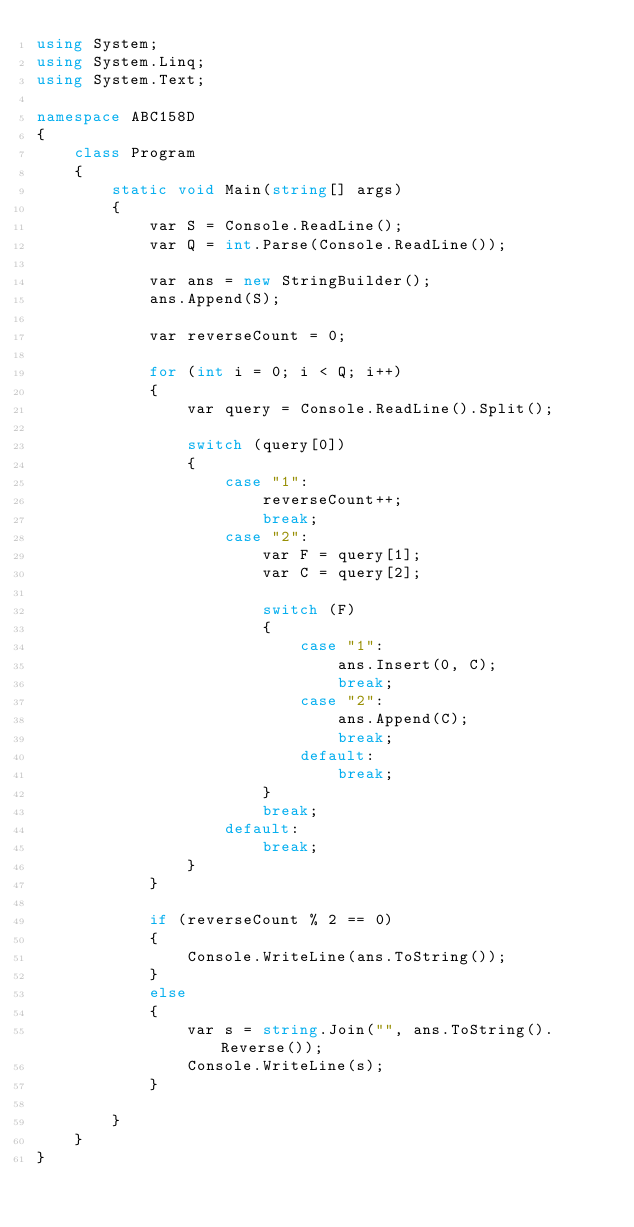Convert code to text. <code><loc_0><loc_0><loc_500><loc_500><_C#_>using System;
using System.Linq;
using System.Text;

namespace ABC158D
{
    class Program
    {
        static void Main(string[] args)
        {
            var S = Console.ReadLine();
            var Q = int.Parse(Console.ReadLine());

            var ans = new StringBuilder();
            ans.Append(S);

            var reverseCount = 0;

            for (int i = 0; i < Q; i++)
            {
                var query = Console.ReadLine().Split();

                switch (query[0])
                {
                    case "1":
                        reverseCount++;
                        break;
                    case "2":
                        var F = query[1];
                        var C = query[2];

                        switch (F)
                        {
                            case "1":
                                ans.Insert(0, C);
                                break;
                            case "2":
                                ans.Append(C);
                                break;
                            default:
                                break;
                        }
                        break;
                    default:
                        break;
                }
            }

            if (reverseCount % 2 == 0)
            {
                Console.WriteLine(ans.ToString());
            }
            else
            {
                var s = string.Join("", ans.ToString().Reverse());
                Console.WriteLine(s);
            }

        }
    }
}
</code> 